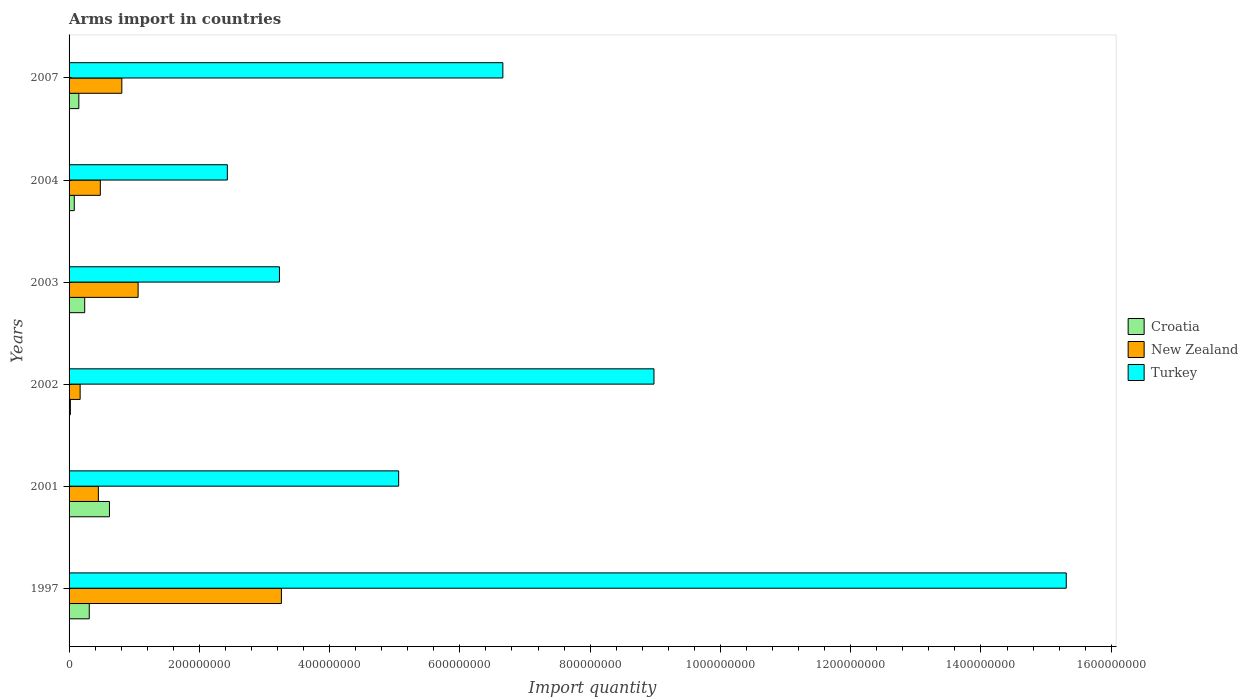Are the number of bars per tick equal to the number of legend labels?
Ensure brevity in your answer.  Yes. How many bars are there on the 4th tick from the top?
Ensure brevity in your answer.  3. How many bars are there on the 1st tick from the bottom?
Provide a short and direct response. 3. What is the total arms import in Croatia in 2001?
Give a very brief answer. 6.20e+07. Across all years, what is the maximum total arms import in Croatia?
Make the answer very short. 6.20e+07. Across all years, what is the minimum total arms import in Turkey?
Give a very brief answer. 2.43e+08. In which year was the total arms import in Croatia maximum?
Offer a terse response. 2001. In which year was the total arms import in Croatia minimum?
Your answer should be compact. 2002. What is the total total arms import in Croatia in the graph?
Your answer should be compact. 1.42e+08. What is the difference between the total arms import in New Zealand in 2001 and that in 2007?
Provide a short and direct response. -3.60e+07. What is the difference between the total arms import in Turkey in 2004 and the total arms import in New Zealand in 1997?
Keep it short and to the point. -8.30e+07. What is the average total arms import in Turkey per year?
Make the answer very short. 6.94e+08. In the year 1997, what is the difference between the total arms import in New Zealand and total arms import in Turkey?
Provide a short and direct response. -1.20e+09. In how many years, is the total arms import in Turkey greater than 480000000 ?
Your response must be concise. 4. What is the ratio of the total arms import in Turkey in 2002 to that in 2003?
Provide a short and direct response. 2.78. Is the total arms import in Turkey in 2003 less than that in 2004?
Provide a succinct answer. No. Is the difference between the total arms import in New Zealand in 2001 and 2002 greater than the difference between the total arms import in Turkey in 2001 and 2002?
Make the answer very short. Yes. What is the difference between the highest and the second highest total arms import in New Zealand?
Your response must be concise. 2.20e+08. What is the difference between the highest and the lowest total arms import in New Zealand?
Your answer should be very brief. 3.09e+08. Is the sum of the total arms import in Croatia in 2001 and 2007 greater than the maximum total arms import in New Zealand across all years?
Make the answer very short. No. What does the 2nd bar from the top in 2002 represents?
Provide a short and direct response. New Zealand. What does the 2nd bar from the bottom in 2001 represents?
Ensure brevity in your answer.  New Zealand. Is it the case that in every year, the sum of the total arms import in Croatia and total arms import in Turkey is greater than the total arms import in New Zealand?
Offer a very short reply. Yes. How many bars are there?
Keep it short and to the point. 18. Are the values on the major ticks of X-axis written in scientific E-notation?
Your response must be concise. No. Does the graph contain any zero values?
Provide a short and direct response. No. Does the graph contain grids?
Your response must be concise. No. What is the title of the graph?
Offer a very short reply. Arms import in countries. Does "Venezuela" appear as one of the legend labels in the graph?
Make the answer very short. No. What is the label or title of the X-axis?
Ensure brevity in your answer.  Import quantity. What is the label or title of the Y-axis?
Provide a succinct answer. Years. What is the Import quantity in Croatia in 1997?
Keep it short and to the point. 3.10e+07. What is the Import quantity of New Zealand in 1997?
Make the answer very short. 3.26e+08. What is the Import quantity of Turkey in 1997?
Provide a succinct answer. 1.53e+09. What is the Import quantity in Croatia in 2001?
Offer a terse response. 6.20e+07. What is the Import quantity in New Zealand in 2001?
Keep it short and to the point. 4.50e+07. What is the Import quantity of Turkey in 2001?
Provide a short and direct response. 5.06e+08. What is the Import quantity of New Zealand in 2002?
Your answer should be very brief. 1.70e+07. What is the Import quantity of Turkey in 2002?
Make the answer very short. 8.98e+08. What is the Import quantity in Croatia in 2003?
Provide a succinct answer. 2.40e+07. What is the Import quantity of New Zealand in 2003?
Your response must be concise. 1.06e+08. What is the Import quantity in Turkey in 2003?
Make the answer very short. 3.23e+08. What is the Import quantity in Croatia in 2004?
Your response must be concise. 8.00e+06. What is the Import quantity of New Zealand in 2004?
Your answer should be very brief. 4.80e+07. What is the Import quantity of Turkey in 2004?
Offer a very short reply. 2.43e+08. What is the Import quantity of Croatia in 2007?
Your response must be concise. 1.50e+07. What is the Import quantity of New Zealand in 2007?
Your answer should be very brief. 8.10e+07. What is the Import quantity in Turkey in 2007?
Your answer should be very brief. 6.66e+08. Across all years, what is the maximum Import quantity in Croatia?
Keep it short and to the point. 6.20e+07. Across all years, what is the maximum Import quantity in New Zealand?
Provide a short and direct response. 3.26e+08. Across all years, what is the maximum Import quantity of Turkey?
Your answer should be very brief. 1.53e+09. Across all years, what is the minimum Import quantity in Croatia?
Provide a short and direct response. 2.00e+06. Across all years, what is the minimum Import quantity of New Zealand?
Your answer should be compact. 1.70e+07. Across all years, what is the minimum Import quantity of Turkey?
Offer a very short reply. 2.43e+08. What is the total Import quantity in Croatia in the graph?
Provide a succinct answer. 1.42e+08. What is the total Import quantity in New Zealand in the graph?
Your response must be concise. 6.23e+08. What is the total Import quantity of Turkey in the graph?
Give a very brief answer. 4.17e+09. What is the difference between the Import quantity in Croatia in 1997 and that in 2001?
Your answer should be very brief. -3.10e+07. What is the difference between the Import quantity of New Zealand in 1997 and that in 2001?
Give a very brief answer. 2.81e+08. What is the difference between the Import quantity of Turkey in 1997 and that in 2001?
Ensure brevity in your answer.  1.02e+09. What is the difference between the Import quantity in Croatia in 1997 and that in 2002?
Your answer should be compact. 2.90e+07. What is the difference between the Import quantity of New Zealand in 1997 and that in 2002?
Offer a terse response. 3.09e+08. What is the difference between the Import quantity in Turkey in 1997 and that in 2002?
Offer a terse response. 6.33e+08. What is the difference between the Import quantity of New Zealand in 1997 and that in 2003?
Give a very brief answer. 2.20e+08. What is the difference between the Import quantity of Turkey in 1997 and that in 2003?
Your answer should be compact. 1.21e+09. What is the difference between the Import quantity in Croatia in 1997 and that in 2004?
Provide a succinct answer. 2.30e+07. What is the difference between the Import quantity in New Zealand in 1997 and that in 2004?
Your answer should be very brief. 2.78e+08. What is the difference between the Import quantity of Turkey in 1997 and that in 2004?
Ensure brevity in your answer.  1.29e+09. What is the difference between the Import quantity of Croatia in 1997 and that in 2007?
Your answer should be very brief. 1.60e+07. What is the difference between the Import quantity in New Zealand in 1997 and that in 2007?
Make the answer very short. 2.45e+08. What is the difference between the Import quantity of Turkey in 1997 and that in 2007?
Keep it short and to the point. 8.65e+08. What is the difference between the Import quantity in Croatia in 2001 and that in 2002?
Your answer should be very brief. 6.00e+07. What is the difference between the Import quantity in New Zealand in 2001 and that in 2002?
Offer a very short reply. 2.80e+07. What is the difference between the Import quantity of Turkey in 2001 and that in 2002?
Your answer should be compact. -3.92e+08. What is the difference between the Import quantity in Croatia in 2001 and that in 2003?
Your answer should be very brief. 3.80e+07. What is the difference between the Import quantity in New Zealand in 2001 and that in 2003?
Give a very brief answer. -6.10e+07. What is the difference between the Import quantity of Turkey in 2001 and that in 2003?
Your answer should be compact. 1.83e+08. What is the difference between the Import quantity in Croatia in 2001 and that in 2004?
Keep it short and to the point. 5.40e+07. What is the difference between the Import quantity in New Zealand in 2001 and that in 2004?
Your response must be concise. -3.00e+06. What is the difference between the Import quantity of Turkey in 2001 and that in 2004?
Keep it short and to the point. 2.63e+08. What is the difference between the Import quantity of Croatia in 2001 and that in 2007?
Keep it short and to the point. 4.70e+07. What is the difference between the Import quantity in New Zealand in 2001 and that in 2007?
Provide a short and direct response. -3.60e+07. What is the difference between the Import quantity of Turkey in 2001 and that in 2007?
Provide a short and direct response. -1.60e+08. What is the difference between the Import quantity of Croatia in 2002 and that in 2003?
Your response must be concise. -2.20e+07. What is the difference between the Import quantity in New Zealand in 2002 and that in 2003?
Your response must be concise. -8.90e+07. What is the difference between the Import quantity of Turkey in 2002 and that in 2003?
Keep it short and to the point. 5.75e+08. What is the difference between the Import quantity in Croatia in 2002 and that in 2004?
Your response must be concise. -6.00e+06. What is the difference between the Import quantity of New Zealand in 2002 and that in 2004?
Give a very brief answer. -3.10e+07. What is the difference between the Import quantity in Turkey in 2002 and that in 2004?
Your response must be concise. 6.55e+08. What is the difference between the Import quantity in Croatia in 2002 and that in 2007?
Provide a short and direct response. -1.30e+07. What is the difference between the Import quantity in New Zealand in 2002 and that in 2007?
Make the answer very short. -6.40e+07. What is the difference between the Import quantity of Turkey in 2002 and that in 2007?
Your answer should be very brief. 2.32e+08. What is the difference between the Import quantity of Croatia in 2003 and that in 2004?
Make the answer very short. 1.60e+07. What is the difference between the Import quantity of New Zealand in 2003 and that in 2004?
Provide a short and direct response. 5.80e+07. What is the difference between the Import quantity in Turkey in 2003 and that in 2004?
Your answer should be very brief. 8.00e+07. What is the difference between the Import quantity in Croatia in 2003 and that in 2007?
Offer a terse response. 9.00e+06. What is the difference between the Import quantity in New Zealand in 2003 and that in 2007?
Your answer should be compact. 2.50e+07. What is the difference between the Import quantity in Turkey in 2003 and that in 2007?
Offer a very short reply. -3.43e+08. What is the difference between the Import quantity of Croatia in 2004 and that in 2007?
Offer a terse response. -7.00e+06. What is the difference between the Import quantity in New Zealand in 2004 and that in 2007?
Provide a succinct answer. -3.30e+07. What is the difference between the Import quantity in Turkey in 2004 and that in 2007?
Keep it short and to the point. -4.23e+08. What is the difference between the Import quantity in Croatia in 1997 and the Import quantity in New Zealand in 2001?
Your answer should be compact. -1.40e+07. What is the difference between the Import quantity of Croatia in 1997 and the Import quantity of Turkey in 2001?
Make the answer very short. -4.75e+08. What is the difference between the Import quantity in New Zealand in 1997 and the Import quantity in Turkey in 2001?
Your answer should be very brief. -1.80e+08. What is the difference between the Import quantity of Croatia in 1997 and the Import quantity of New Zealand in 2002?
Make the answer very short. 1.40e+07. What is the difference between the Import quantity of Croatia in 1997 and the Import quantity of Turkey in 2002?
Provide a succinct answer. -8.67e+08. What is the difference between the Import quantity of New Zealand in 1997 and the Import quantity of Turkey in 2002?
Offer a very short reply. -5.72e+08. What is the difference between the Import quantity in Croatia in 1997 and the Import quantity in New Zealand in 2003?
Give a very brief answer. -7.50e+07. What is the difference between the Import quantity of Croatia in 1997 and the Import quantity of Turkey in 2003?
Your answer should be very brief. -2.92e+08. What is the difference between the Import quantity in Croatia in 1997 and the Import quantity in New Zealand in 2004?
Provide a succinct answer. -1.70e+07. What is the difference between the Import quantity in Croatia in 1997 and the Import quantity in Turkey in 2004?
Ensure brevity in your answer.  -2.12e+08. What is the difference between the Import quantity of New Zealand in 1997 and the Import quantity of Turkey in 2004?
Your answer should be compact. 8.30e+07. What is the difference between the Import quantity of Croatia in 1997 and the Import quantity of New Zealand in 2007?
Make the answer very short. -5.00e+07. What is the difference between the Import quantity in Croatia in 1997 and the Import quantity in Turkey in 2007?
Offer a very short reply. -6.35e+08. What is the difference between the Import quantity of New Zealand in 1997 and the Import quantity of Turkey in 2007?
Your answer should be compact. -3.40e+08. What is the difference between the Import quantity in Croatia in 2001 and the Import quantity in New Zealand in 2002?
Offer a very short reply. 4.50e+07. What is the difference between the Import quantity of Croatia in 2001 and the Import quantity of Turkey in 2002?
Your answer should be very brief. -8.36e+08. What is the difference between the Import quantity in New Zealand in 2001 and the Import quantity in Turkey in 2002?
Provide a succinct answer. -8.53e+08. What is the difference between the Import quantity of Croatia in 2001 and the Import quantity of New Zealand in 2003?
Your answer should be compact. -4.40e+07. What is the difference between the Import quantity in Croatia in 2001 and the Import quantity in Turkey in 2003?
Offer a terse response. -2.61e+08. What is the difference between the Import quantity in New Zealand in 2001 and the Import quantity in Turkey in 2003?
Your answer should be compact. -2.78e+08. What is the difference between the Import quantity of Croatia in 2001 and the Import quantity of New Zealand in 2004?
Make the answer very short. 1.40e+07. What is the difference between the Import quantity of Croatia in 2001 and the Import quantity of Turkey in 2004?
Offer a terse response. -1.81e+08. What is the difference between the Import quantity of New Zealand in 2001 and the Import quantity of Turkey in 2004?
Your answer should be compact. -1.98e+08. What is the difference between the Import quantity of Croatia in 2001 and the Import quantity of New Zealand in 2007?
Your answer should be compact. -1.90e+07. What is the difference between the Import quantity of Croatia in 2001 and the Import quantity of Turkey in 2007?
Your answer should be compact. -6.04e+08. What is the difference between the Import quantity in New Zealand in 2001 and the Import quantity in Turkey in 2007?
Ensure brevity in your answer.  -6.21e+08. What is the difference between the Import quantity of Croatia in 2002 and the Import quantity of New Zealand in 2003?
Your response must be concise. -1.04e+08. What is the difference between the Import quantity in Croatia in 2002 and the Import quantity in Turkey in 2003?
Offer a terse response. -3.21e+08. What is the difference between the Import quantity of New Zealand in 2002 and the Import quantity of Turkey in 2003?
Provide a short and direct response. -3.06e+08. What is the difference between the Import quantity in Croatia in 2002 and the Import quantity in New Zealand in 2004?
Make the answer very short. -4.60e+07. What is the difference between the Import quantity in Croatia in 2002 and the Import quantity in Turkey in 2004?
Provide a short and direct response. -2.41e+08. What is the difference between the Import quantity in New Zealand in 2002 and the Import quantity in Turkey in 2004?
Offer a very short reply. -2.26e+08. What is the difference between the Import quantity of Croatia in 2002 and the Import quantity of New Zealand in 2007?
Provide a short and direct response. -7.90e+07. What is the difference between the Import quantity of Croatia in 2002 and the Import quantity of Turkey in 2007?
Provide a succinct answer. -6.64e+08. What is the difference between the Import quantity of New Zealand in 2002 and the Import quantity of Turkey in 2007?
Give a very brief answer. -6.49e+08. What is the difference between the Import quantity in Croatia in 2003 and the Import quantity in New Zealand in 2004?
Your answer should be very brief. -2.40e+07. What is the difference between the Import quantity of Croatia in 2003 and the Import quantity of Turkey in 2004?
Provide a short and direct response. -2.19e+08. What is the difference between the Import quantity of New Zealand in 2003 and the Import quantity of Turkey in 2004?
Keep it short and to the point. -1.37e+08. What is the difference between the Import quantity of Croatia in 2003 and the Import quantity of New Zealand in 2007?
Provide a succinct answer. -5.70e+07. What is the difference between the Import quantity of Croatia in 2003 and the Import quantity of Turkey in 2007?
Your answer should be very brief. -6.42e+08. What is the difference between the Import quantity of New Zealand in 2003 and the Import quantity of Turkey in 2007?
Offer a terse response. -5.60e+08. What is the difference between the Import quantity in Croatia in 2004 and the Import quantity in New Zealand in 2007?
Your answer should be very brief. -7.30e+07. What is the difference between the Import quantity of Croatia in 2004 and the Import quantity of Turkey in 2007?
Provide a short and direct response. -6.58e+08. What is the difference between the Import quantity in New Zealand in 2004 and the Import quantity in Turkey in 2007?
Your answer should be very brief. -6.18e+08. What is the average Import quantity in Croatia per year?
Ensure brevity in your answer.  2.37e+07. What is the average Import quantity of New Zealand per year?
Your answer should be compact. 1.04e+08. What is the average Import quantity of Turkey per year?
Give a very brief answer. 6.94e+08. In the year 1997, what is the difference between the Import quantity of Croatia and Import quantity of New Zealand?
Keep it short and to the point. -2.95e+08. In the year 1997, what is the difference between the Import quantity of Croatia and Import quantity of Turkey?
Your response must be concise. -1.50e+09. In the year 1997, what is the difference between the Import quantity in New Zealand and Import quantity in Turkey?
Give a very brief answer. -1.20e+09. In the year 2001, what is the difference between the Import quantity of Croatia and Import quantity of New Zealand?
Give a very brief answer. 1.70e+07. In the year 2001, what is the difference between the Import quantity of Croatia and Import quantity of Turkey?
Your answer should be compact. -4.44e+08. In the year 2001, what is the difference between the Import quantity of New Zealand and Import quantity of Turkey?
Your answer should be very brief. -4.61e+08. In the year 2002, what is the difference between the Import quantity in Croatia and Import quantity in New Zealand?
Your answer should be very brief. -1.50e+07. In the year 2002, what is the difference between the Import quantity in Croatia and Import quantity in Turkey?
Offer a very short reply. -8.96e+08. In the year 2002, what is the difference between the Import quantity of New Zealand and Import quantity of Turkey?
Ensure brevity in your answer.  -8.81e+08. In the year 2003, what is the difference between the Import quantity in Croatia and Import quantity in New Zealand?
Your response must be concise. -8.20e+07. In the year 2003, what is the difference between the Import quantity in Croatia and Import quantity in Turkey?
Provide a succinct answer. -2.99e+08. In the year 2003, what is the difference between the Import quantity in New Zealand and Import quantity in Turkey?
Give a very brief answer. -2.17e+08. In the year 2004, what is the difference between the Import quantity in Croatia and Import quantity in New Zealand?
Your answer should be very brief. -4.00e+07. In the year 2004, what is the difference between the Import quantity in Croatia and Import quantity in Turkey?
Provide a succinct answer. -2.35e+08. In the year 2004, what is the difference between the Import quantity in New Zealand and Import quantity in Turkey?
Your response must be concise. -1.95e+08. In the year 2007, what is the difference between the Import quantity in Croatia and Import quantity in New Zealand?
Keep it short and to the point. -6.60e+07. In the year 2007, what is the difference between the Import quantity of Croatia and Import quantity of Turkey?
Provide a succinct answer. -6.51e+08. In the year 2007, what is the difference between the Import quantity in New Zealand and Import quantity in Turkey?
Ensure brevity in your answer.  -5.85e+08. What is the ratio of the Import quantity of New Zealand in 1997 to that in 2001?
Offer a terse response. 7.24. What is the ratio of the Import quantity in Turkey in 1997 to that in 2001?
Your answer should be compact. 3.03. What is the ratio of the Import quantity of Croatia in 1997 to that in 2002?
Keep it short and to the point. 15.5. What is the ratio of the Import quantity of New Zealand in 1997 to that in 2002?
Make the answer very short. 19.18. What is the ratio of the Import quantity of Turkey in 1997 to that in 2002?
Your answer should be very brief. 1.7. What is the ratio of the Import quantity of Croatia in 1997 to that in 2003?
Provide a succinct answer. 1.29. What is the ratio of the Import quantity of New Zealand in 1997 to that in 2003?
Provide a short and direct response. 3.08. What is the ratio of the Import quantity in Turkey in 1997 to that in 2003?
Your answer should be very brief. 4.74. What is the ratio of the Import quantity of Croatia in 1997 to that in 2004?
Your answer should be compact. 3.88. What is the ratio of the Import quantity of New Zealand in 1997 to that in 2004?
Provide a succinct answer. 6.79. What is the ratio of the Import quantity of Turkey in 1997 to that in 2004?
Offer a terse response. 6.3. What is the ratio of the Import quantity in Croatia in 1997 to that in 2007?
Keep it short and to the point. 2.07. What is the ratio of the Import quantity of New Zealand in 1997 to that in 2007?
Your answer should be compact. 4.02. What is the ratio of the Import quantity of Turkey in 1997 to that in 2007?
Offer a very short reply. 2.3. What is the ratio of the Import quantity of Croatia in 2001 to that in 2002?
Your answer should be very brief. 31. What is the ratio of the Import quantity of New Zealand in 2001 to that in 2002?
Offer a very short reply. 2.65. What is the ratio of the Import quantity in Turkey in 2001 to that in 2002?
Provide a succinct answer. 0.56. What is the ratio of the Import quantity in Croatia in 2001 to that in 2003?
Offer a terse response. 2.58. What is the ratio of the Import quantity of New Zealand in 2001 to that in 2003?
Your answer should be very brief. 0.42. What is the ratio of the Import quantity in Turkey in 2001 to that in 2003?
Give a very brief answer. 1.57. What is the ratio of the Import quantity in Croatia in 2001 to that in 2004?
Make the answer very short. 7.75. What is the ratio of the Import quantity of New Zealand in 2001 to that in 2004?
Give a very brief answer. 0.94. What is the ratio of the Import quantity in Turkey in 2001 to that in 2004?
Your answer should be very brief. 2.08. What is the ratio of the Import quantity in Croatia in 2001 to that in 2007?
Ensure brevity in your answer.  4.13. What is the ratio of the Import quantity of New Zealand in 2001 to that in 2007?
Your answer should be compact. 0.56. What is the ratio of the Import quantity in Turkey in 2001 to that in 2007?
Your answer should be compact. 0.76. What is the ratio of the Import quantity in Croatia in 2002 to that in 2003?
Ensure brevity in your answer.  0.08. What is the ratio of the Import quantity in New Zealand in 2002 to that in 2003?
Provide a succinct answer. 0.16. What is the ratio of the Import quantity of Turkey in 2002 to that in 2003?
Offer a terse response. 2.78. What is the ratio of the Import quantity of Croatia in 2002 to that in 2004?
Provide a succinct answer. 0.25. What is the ratio of the Import quantity of New Zealand in 2002 to that in 2004?
Make the answer very short. 0.35. What is the ratio of the Import quantity in Turkey in 2002 to that in 2004?
Provide a short and direct response. 3.7. What is the ratio of the Import quantity in Croatia in 2002 to that in 2007?
Offer a terse response. 0.13. What is the ratio of the Import quantity in New Zealand in 2002 to that in 2007?
Give a very brief answer. 0.21. What is the ratio of the Import quantity of Turkey in 2002 to that in 2007?
Offer a very short reply. 1.35. What is the ratio of the Import quantity of Croatia in 2003 to that in 2004?
Ensure brevity in your answer.  3. What is the ratio of the Import quantity of New Zealand in 2003 to that in 2004?
Ensure brevity in your answer.  2.21. What is the ratio of the Import quantity in Turkey in 2003 to that in 2004?
Provide a short and direct response. 1.33. What is the ratio of the Import quantity in New Zealand in 2003 to that in 2007?
Give a very brief answer. 1.31. What is the ratio of the Import quantity of Turkey in 2003 to that in 2007?
Ensure brevity in your answer.  0.48. What is the ratio of the Import quantity of Croatia in 2004 to that in 2007?
Offer a very short reply. 0.53. What is the ratio of the Import quantity of New Zealand in 2004 to that in 2007?
Give a very brief answer. 0.59. What is the ratio of the Import quantity in Turkey in 2004 to that in 2007?
Offer a terse response. 0.36. What is the difference between the highest and the second highest Import quantity of Croatia?
Ensure brevity in your answer.  3.10e+07. What is the difference between the highest and the second highest Import quantity of New Zealand?
Offer a terse response. 2.20e+08. What is the difference between the highest and the second highest Import quantity in Turkey?
Offer a terse response. 6.33e+08. What is the difference between the highest and the lowest Import quantity in Croatia?
Give a very brief answer. 6.00e+07. What is the difference between the highest and the lowest Import quantity of New Zealand?
Offer a terse response. 3.09e+08. What is the difference between the highest and the lowest Import quantity of Turkey?
Offer a terse response. 1.29e+09. 